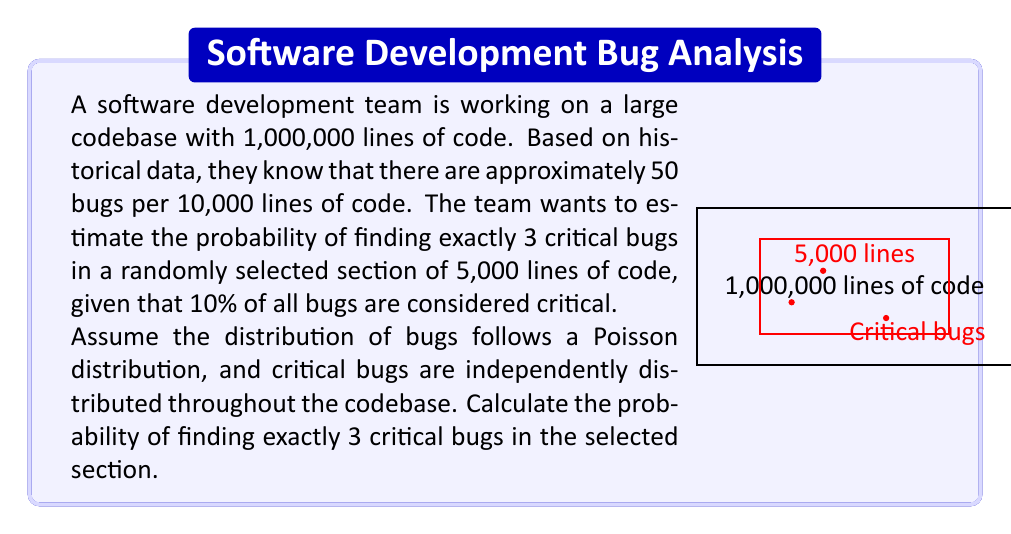Solve this math problem. Let's approach this step-by-step:

1) First, we need to calculate the average number of bugs in 5,000 lines of code:
   $$ \lambda_{total} = \frac{50 \text{ bugs}}{10,000 \text{ lines}} \times 5,000 \text{ lines} = 25 \text{ bugs} $$

2) Now, we need to determine the average number of critical bugs in 5,000 lines:
   $$ \lambda_{critical} = 10\% \times 25 = 2.5 \text{ critical bugs} $$

3) We're using a Poisson distribution to model this scenario. The probability mass function for a Poisson distribution is:
   $$ P(X = k) = \frac{e^{-\lambda} \lambda^k}{k!} $$
   where $\lambda$ is the average number of occurrences and $k$ is the number of occurrences we're interested in.

4) In our case, $\lambda = 2.5$ and $k = 3$. Let's substitute these values:
   $$ P(X = 3) = \frac{e^{-2.5} 2.5^3}{3!} $$

5) Now let's calculate this step-by-step:
   $$ P(X = 3) = \frac{e^{-2.5} \times 15.625}{6} $$
   $$ = \frac{0.082085 \times 15.625}{6} $$
   $$ = \frac{1.282578}{6} $$
   $$ \approx 0.2137630 $$

6) Converting to a percentage:
   $$ 0.2137630 \times 100\% \approx 21.38\% $$

Therefore, the probability of finding exactly 3 critical bugs in the randomly selected 5,000 lines of code is approximately 21.38%.
Answer: $21.38\%$ 